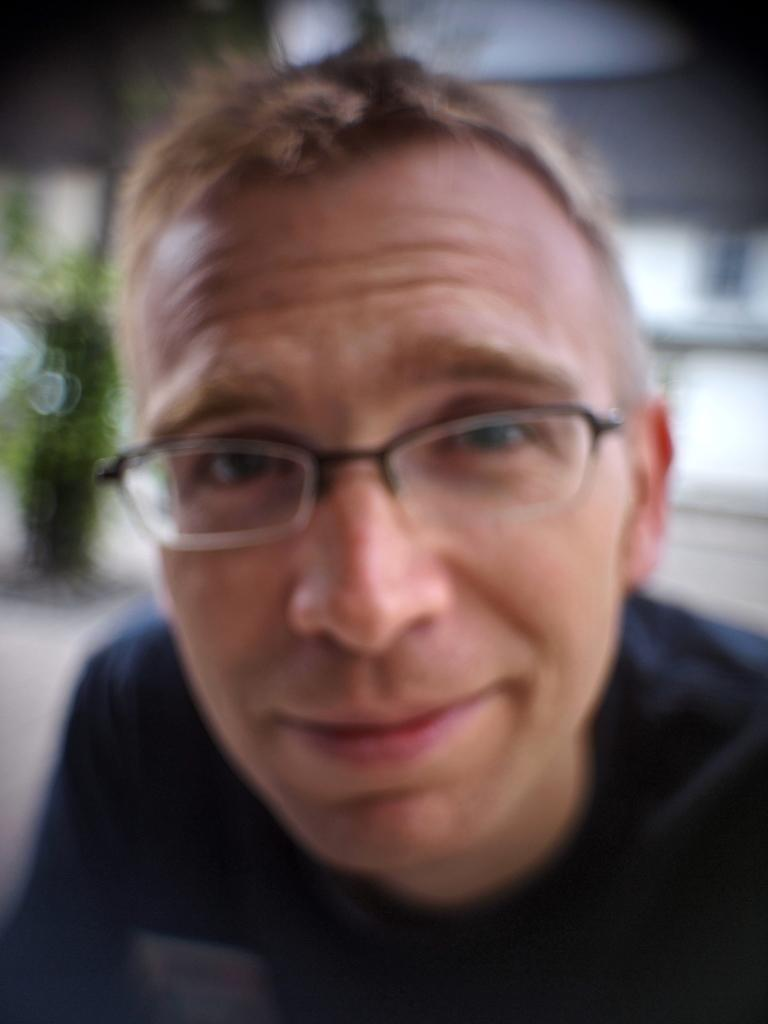What is the main subject of the image? There is a person in the image. Can you describe any specific features of the person? The person is wearing spectacles. What can be observed about the background of the image? The background of the image is blurry. What type of alarm can be heard going off in the image? There is no alarm present in the image, and therefore no such sound can be heard. Can you see any rod-like objects in the image? There is no rod-like object present in the image. Is there a cat visible in the image? There is no cat visible in the image. 